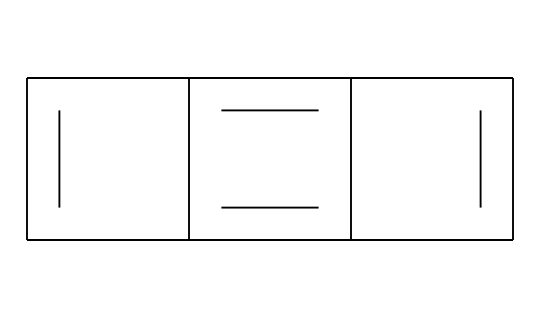What is the main component of graphite pencil lead? The SMILES representation indicates a structure primarily composed of carbon atoms. Graphite pencil lead is mainly made of carbon arranged in a specific planar structure, which is characteristic of graphite.
Answer: carbon How many carbon atoms are present in this structure? By analyzing the SMILES notation, we can identify that there are a total of 6 carbon atoms present in the structure, which corresponds to the carbon atoms in graphite.
Answer: 6 What type of bonding is predominantly found in graphite lead? The structure reveals that there are multiple double bonds and resonance among the carbon atoms. This indicates that the carbon atoms are held together by covalent bonds, typical of carbon in graphite.
Answer: covalent bonds What is the hybridization state of the carbon atoms in the structure? Each carbon atom in graphite typically has a sp2 hybridization because they form three sigma bonds and one pi bond with neighboring carbon atoms. This hybridization leads to a planar structure.
Answer: sp2 How does the arrangement of carbon atoms affect the properties of graphite? The planar arrangement with delocalized electrons allows graphite to have lubricating properties and good conductivity, due to the ability of electrons to move freely across the layers.
Answer: lubrication and conductivity 